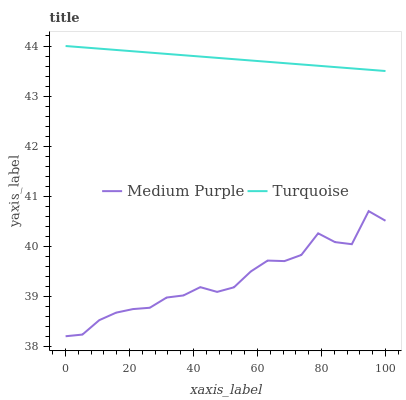Does Medium Purple have the minimum area under the curve?
Answer yes or no. Yes. Does Turquoise have the maximum area under the curve?
Answer yes or no. Yes. Does Turquoise have the minimum area under the curve?
Answer yes or no. No. Is Turquoise the smoothest?
Answer yes or no. Yes. Is Medium Purple the roughest?
Answer yes or no. Yes. Is Turquoise the roughest?
Answer yes or no. No. Does Medium Purple have the lowest value?
Answer yes or no. Yes. Does Turquoise have the lowest value?
Answer yes or no. No. Does Turquoise have the highest value?
Answer yes or no. Yes. Is Medium Purple less than Turquoise?
Answer yes or no. Yes. Is Turquoise greater than Medium Purple?
Answer yes or no. Yes. Does Medium Purple intersect Turquoise?
Answer yes or no. No. 